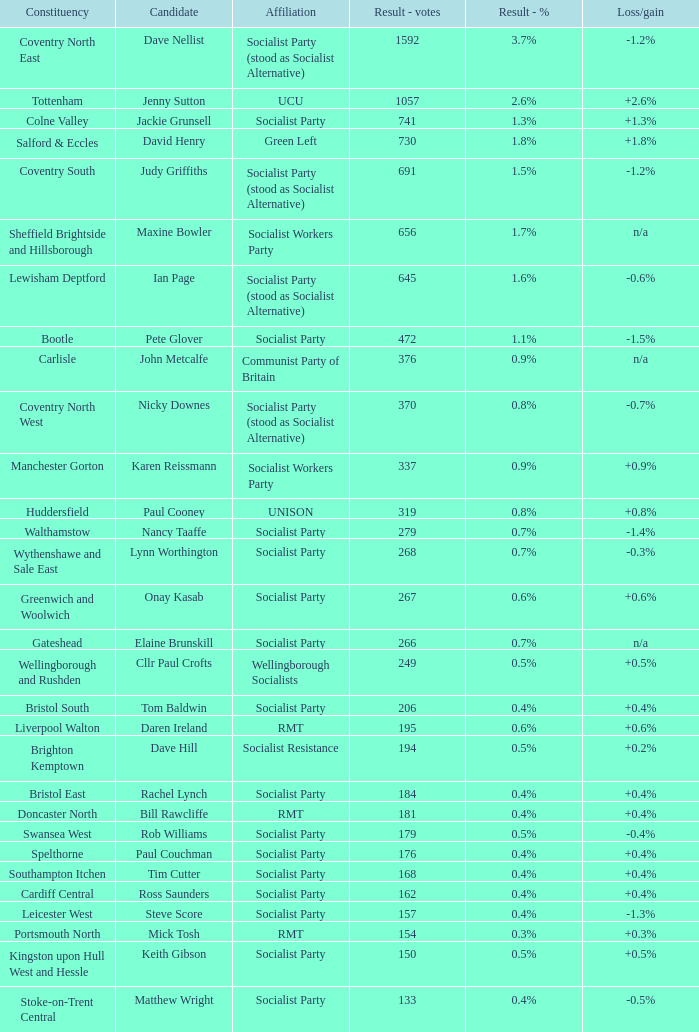5%? 133.0. 